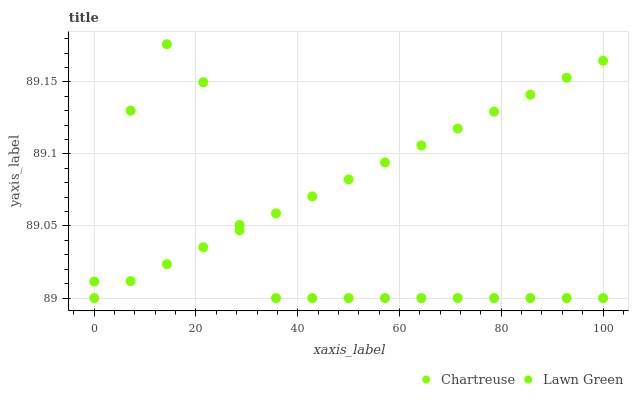Does Lawn Green have the minimum area under the curve?
Answer yes or no. Yes. Does Chartreuse have the maximum area under the curve?
Answer yes or no. Yes. Does Chartreuse have the minimum area under the curve?
Answer yes or no. No. Is Chartreuse the smoothest?
Answer yes or no. Yes. Is Lawn Green the roughest?
Answer yes or no. Yes. Is Chartreuse the roughest?
Answer yes or no. No. Does Lawn Green have the lowest value?
Answer yes or no. Yes. Does Lawn Green have the highest value?
Answer yes or no. Yes. Does Chartreuse have the highest value?
Answer yes or no. No. Does Lawn Green intersect Chartreuse?
Answer yes or no. Yes. Is Lawn Green less than Chartreuse?
Answer yes or no. No. Is Lawn Green greater than Chartreuse?
Answer yes or no. No. 